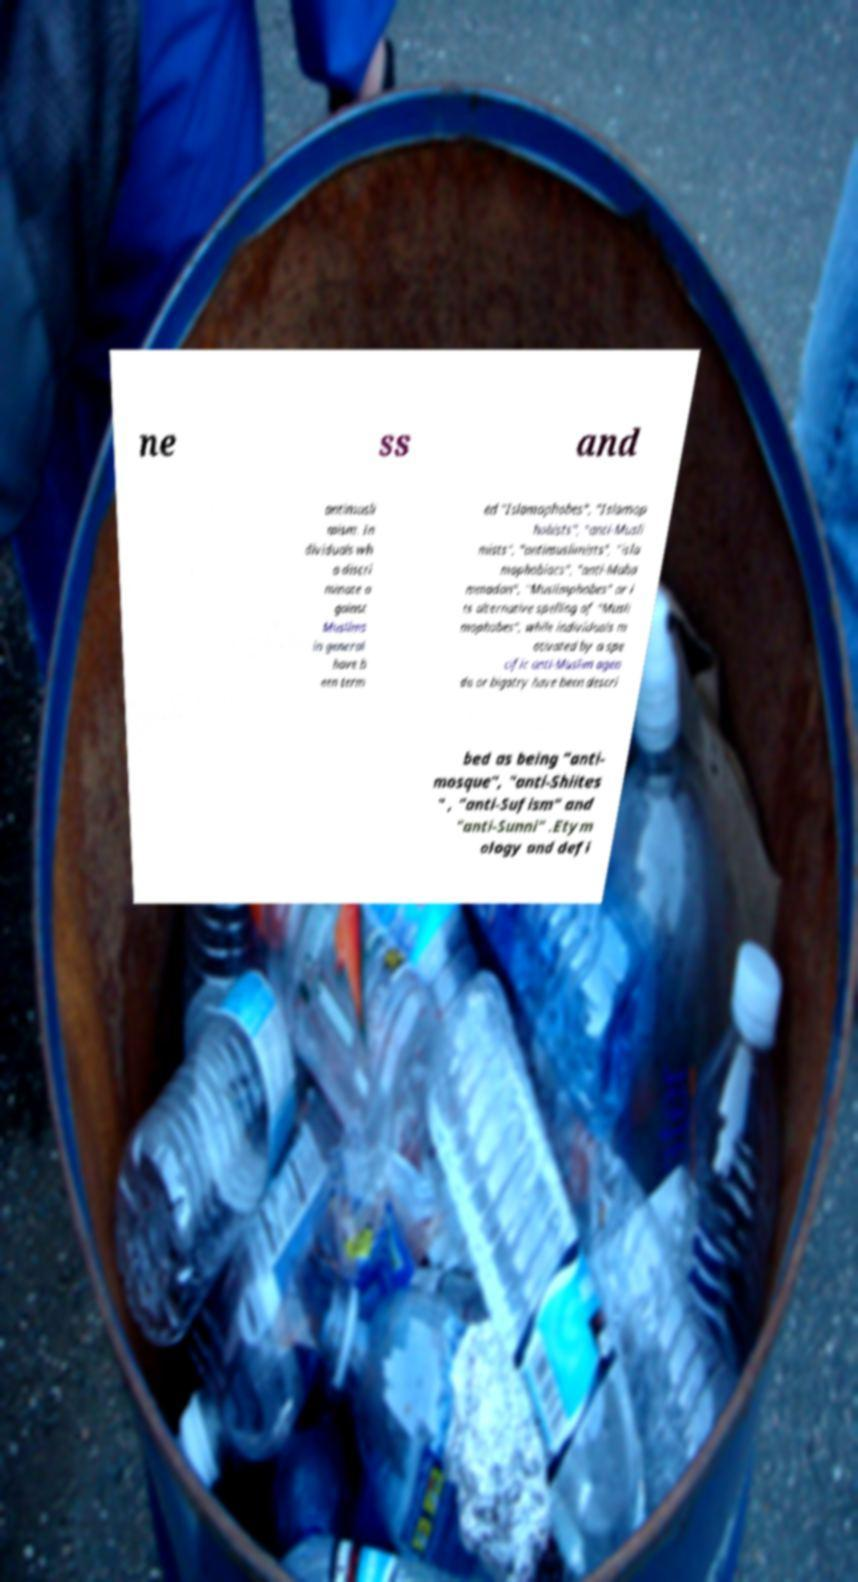I need the written content from this picture converted into text. Can you do that? ne ss and antimusli mism. In dividuals wh o discri minate a gainst Muslims in general have b een term ed "Islamophobes", "Islamop hobists", "anti-Musli mists", "antimuslimists", "isla mophobiacs", "anti-Muha mmadan", "Muslimphobes" or i ts alternative spelling of "Musli mophobes", while individuals m otivated by a spe cific anti-Muslim agen da or bigotry have been descri bed as being "anti- mosque", "anti-Shiites " , "anti-Sufism" and "anti-Sunni" .Etym ology and defi 